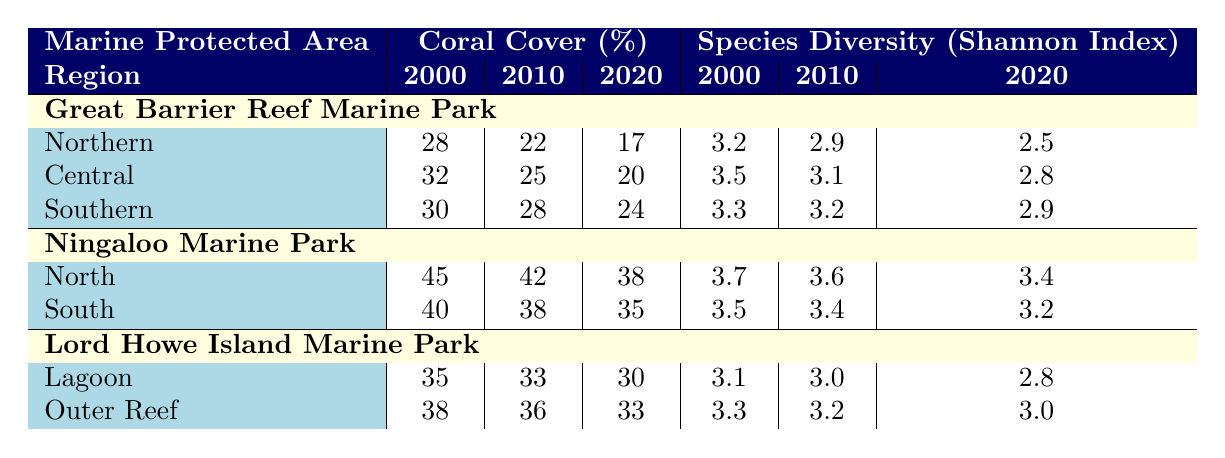What was the coral cover percentage in the Northern region of the Great Barrier Reef Marine Park in 2020? From the table, refer to the Great Barrier Reef Marine Park and locate the Northern region. The coral cover percentage for that region in 2020 is listed as 17%.
Answer: 17% Which region in Ningaloo Marine Park had the highest coral cover in 2000? Looking at the table for Ningaloo Marine Park, the North region has a coral cover of 45% in 2000, which is higher than the South region's 40%.
Answer: North What is the average coral cover for the Southern region of the Great Barrier Reef Marine Park from 2000 to 2020? The values for coral cover in the Southern region are 30% (2000), 28% (2010), and 24% (2020). Adding these values together gives 30 + 28 + 24 = 82. Dividing by the number of data points (3) gives an average of 82/3 ≈ 27.33%.
Answer: 27.33% How much did coral cover decline in the Central region of the Great Barrier Reef Marine Park from 2000 to 2020? In the Central region, the coral cover was 32% in 2000 and 20% in 2020. The decline can be calculated by subtracting the 2020 value from the 2000 value: 32 - 20 = 12%.
Answer: 12% Is the Shannon Index for species diversity consistently decreasing from 2000 to 2020 in the Southern region of the Great Barrier Reef Marine Park? The Shannon Index values for the Southern region are 3.3 (2000), 3.2 (2010), and 2.9 (2020). Each subsequent year shows a decrease: from 3.3 to 3.2 and from 3.2 to 2.9, indicating a consistent decline.
Answer: Yes Which marine park region had the highest species diversity Shannon Index in 2010? Looking through the table, the North region of Ningaloo Marine Park has the highest Shannon Index of 3.6 in 2010, compared to other regions and years listed.
Answer: North region of Ningaloo Marine Park What are the coral cover percentages for the Lagoon region of Lord Howe Island Marine Park from 2000 to 2020? Referring to the Lord Howe Island Marine Park section, the coral cover percentages for the Lagoon region are 35% in 2000, 33% in 2010, and 30% in 2020.
Answer: 35%, 33%, 30% How much greater was the species diversity in the North region of Ningaloo Marine Park compared to the South region in 2000? The Shannon Index for the North region in 2000 is 3.7, and for the South region, it is 3.5. The difference is 3.7 - 3.5 = 0.2, indicating that the North region had greater diversity.
Answer: 0.2 What is the total coral cover for the Great Barrier Reef Marine Park across all regions in 2010? The coral cover for the regions in 2010 are 22% (Northern), 25% (Central), and 28% (Southern). Adding these values gives 22 + 25 + 28 = 75%.
Answer: 75% Did the Outer Reef region of Lord Howe Island Marine Park experience an increase or decrease in species diversity from 2000 to 2020? The Shannon Index values for the Outer Reef are 3.3 (2000) and 3.0 (2020). There is a decrease from 3.3 to 3.0, indicating a decline in species diversity over this period.
Answer: Decrease 